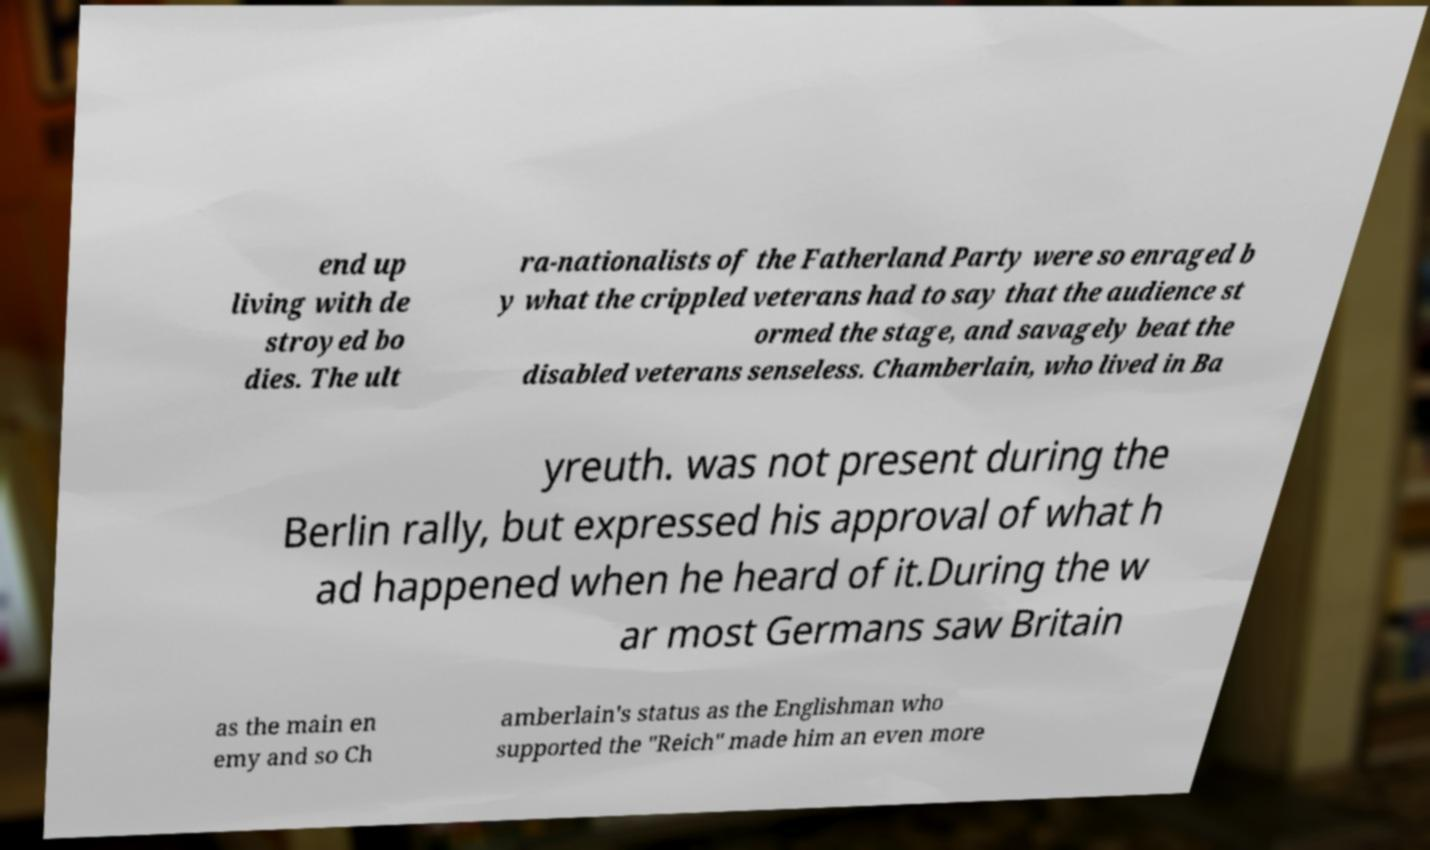Please identify and transcribe the text found in this image. end up living with de stroyed bo dies. The ult ra-nationalists of the Fatherland Party were so enraged b y what the crippled veterans had to say that the audience st ormed the stage, and savagely beat the disabled veterans senseless. Chamberlain, who lived in Ba yreuth. was not present during the Berlin rally, but expressed his approval of what h ad happened when he heard of it.During the w ar most Germans saw Britain as the main en emy and so Ch amberlain's status as the Englishman who supported the "Reich" made him an even more 